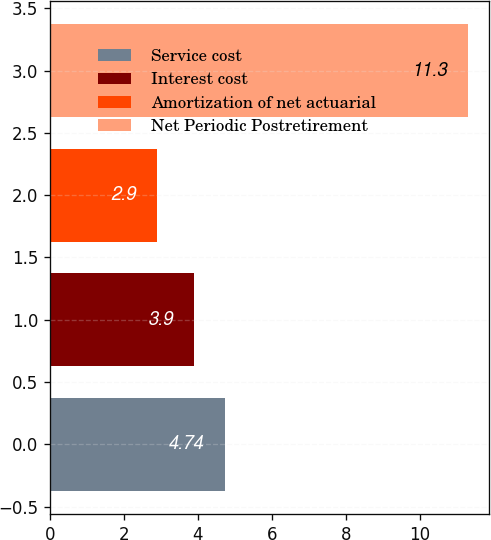Convert chart to OTSL. <chart><loc_0><loc_0><loc_500><loc_500><bar_chart><fcel>Service cost<fcel>Interest cost<fcel>Amortization of net actuarial<fcel>Net Periodic Postretirement<nl><fcel>4.74<fcel>3.9<fcel>2.9<fcel>11.3<nl></chart> 